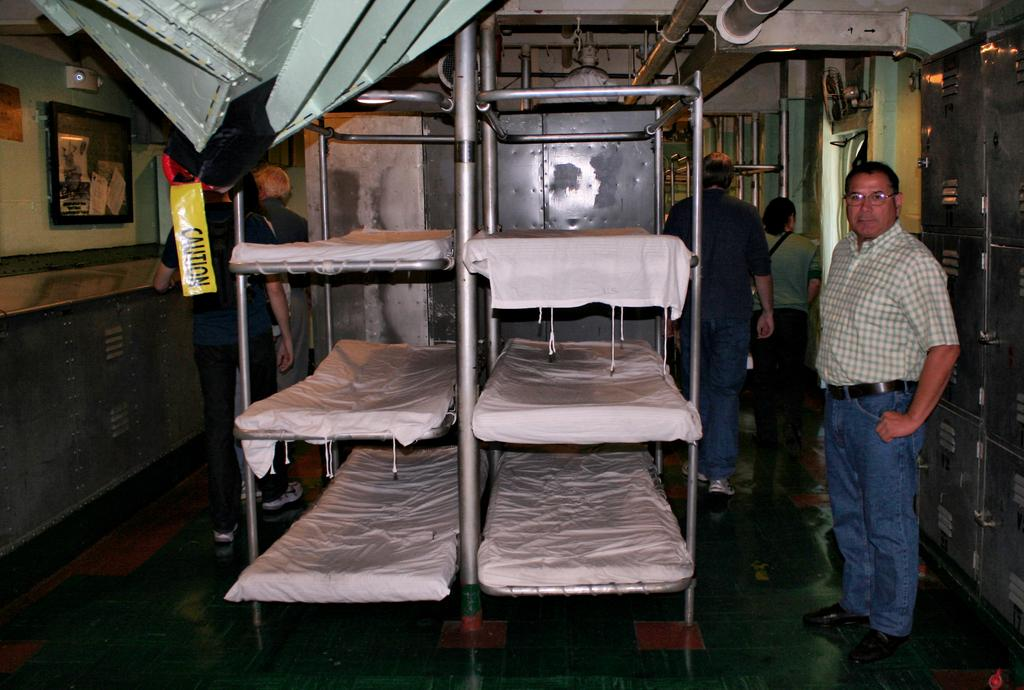<image>
Summarize the visual content of the image. the word caution is on the yellow sign in the room 